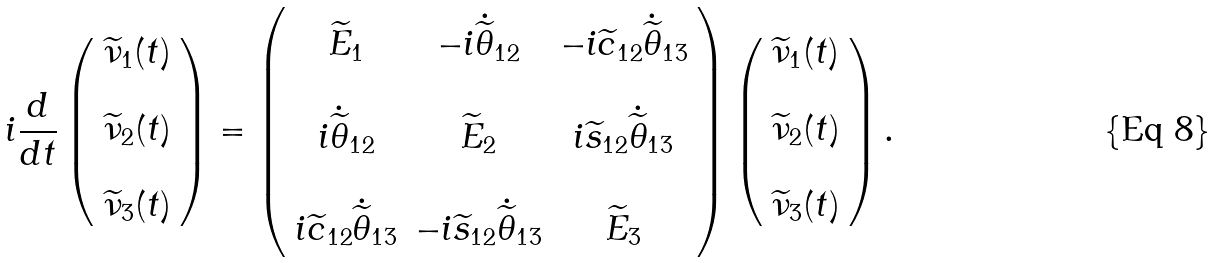<formula> <loc_0><loc_0><loc_500><loc_500>i \frac { d } { d t } \left ( \begin{array} { c } \widetilde { \nu } _ { 1 } ( t ) \\ \\ \widetilde { \nu } _ { 2 } ( t ) \\ \\ \widetilde { \nu } _ { 3 } ( t ) \end{array} \right ) = \left ( \begin{array} { c c c } \widetilde { E } _ { 1 } & - i \dot { \widetilde { \theta } } _ { 1 2 } & - i \widetilde { c } _ { 1 2 } \dot { \widetilde { \theta } } _ { 1 3 } \\ & & \\ i \dot { \widetilde { \theta } } _ { 1 2 } & \widetilde { E } _ { 2 } & i \widetilde { s } _ { 1 2 } \dot { \widetilde { \theta } } _ { 1 3 } \\ & & \\ i \widetilde { c } _ { 1 2 } \dot { \widetilde { \theta } } _ { 1 3 } & - i \widetilde { s } _ { 1 2 } \dot { \widetilde { \theta } } _ { 1 3 } & \widetilde { E } _ { 3 } \end{array} \right ) \left ( \begin{array} { c } \widetilde { \nu } _ { 1 } ( t ) \\ \\ \widetilde { \nu } _ { 2 } ( t ) \\ \\ \widetilde { \nu } _ { 3 } ( t ) \end{array} \right ) .</formula> 